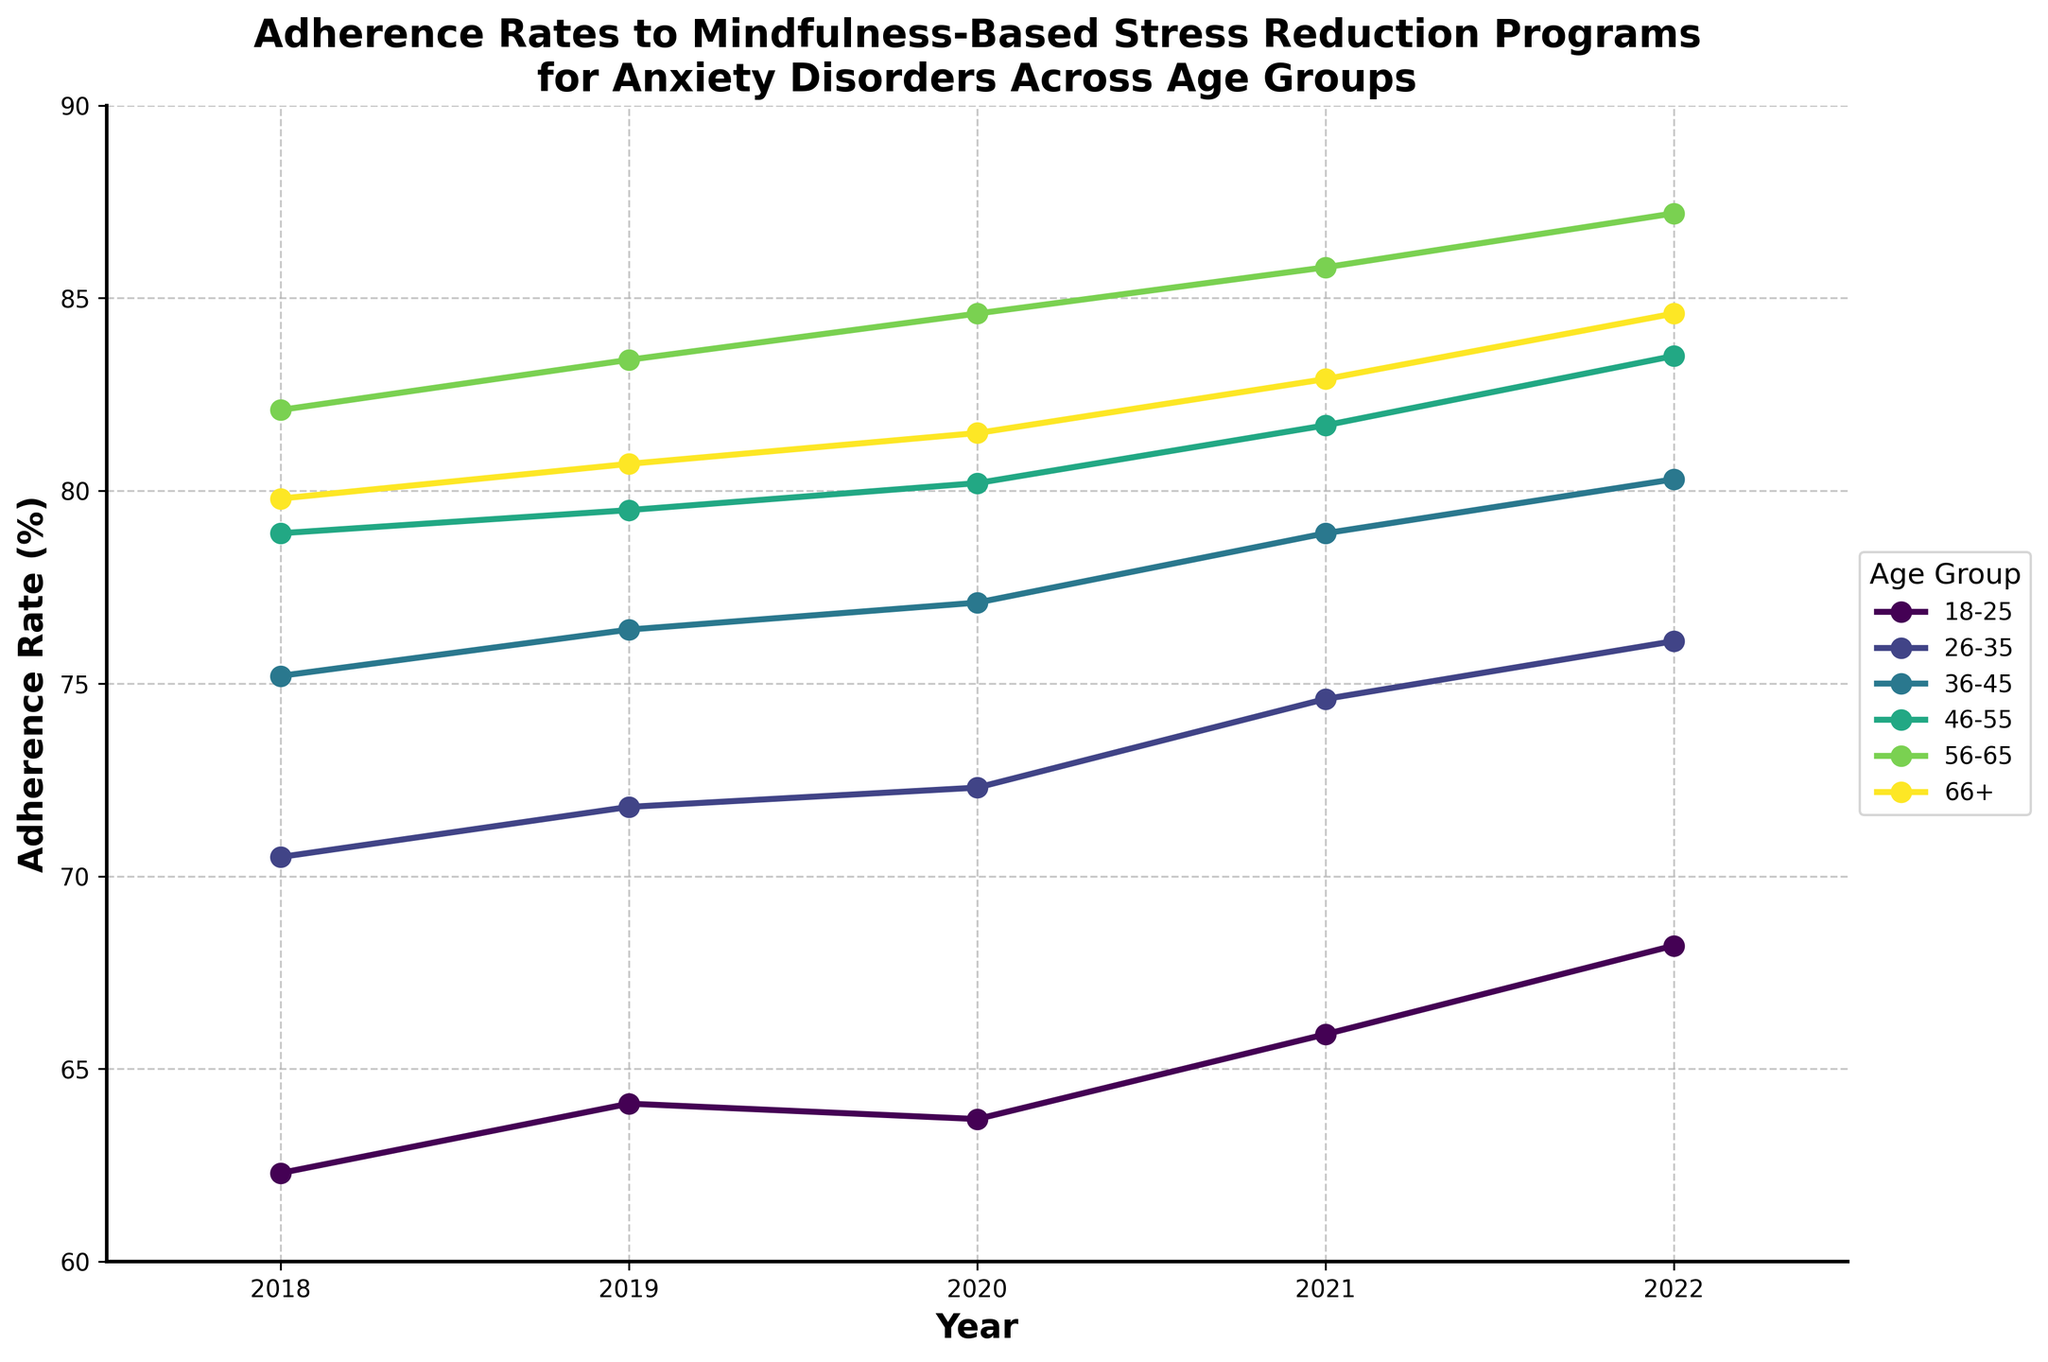Which age group has the highest adherence rate in 2022? To answer this, look at the adherence rates for each age group in 2022. The age groups have the following adherence rates: 18-25 (68.2), 26-35 (76.1), 36-45 (80.3), 46-55 (83.5), 56-65 (87.2), and 66+ (84.6). The highest adherence rate is 87.2 for the age group 56-65.
Answer: 56-65 How has the adherence rate for the 36-45 age group changed from 2018 to 2022? To find this, subtract the adherence rate in 2018 from the adherence rate in 2022 for the 36-45 age group. The adherence rates are: 2018 (75.2) and 2022 (80.3). Thus, the change is 80.3 - 75.2 = 5.1.
Answer: Increased by 5.1 Which age group showed the least improvement in adherence rate from 2018 to 2022? Calculate the difference in adherence rates from 2018 to 2022 for each age group. The differences are as follows: 18-25 (68.2 - 62.3 = 5.9), 26-35 (76.1 - 70.5 = 5.6), 36-45 (80.3 - 75.2 = 5.1), 46-55 (83.5 - 78.9 = 4.6), 56-65 (87.2 - 82.1 = 5.1), 66+ (84.6 - 79.8 = 4.8). The smallest difference is for the 46-55 age group, which is 4.6.
Answer: 46-55 Which year shows the largest overall base adherence rate increase across all age groups? Sum the adherence rates for all age groups for each year and compare the year-over-year growth. 2018: 62.3 + 70.5 + 75.2 + 78.9 + 82.1 + 79.8 = 448.8, 2019: 64.1 + 71.8 + 76.4 + 79.5 + 83.4 + 80.7 = 455.9, Δ 2019-2018 = 7.1. 2020: 63.7 + 72.3 + 77.1 + 80.2 + 84.6 + 81.5 = 459.4, Δ 2020-2019 = 3.5. 2021: 65.9 + 74.6 + 78.9 + 81.7 + 85.8 + 82.9 = 469.8, Δ 2021-2020 = 10.4. 2022: 68.2 + 76.1 + 80.3 + 83.5 + 87.2 + 84.6 = 479.9, Δ 2022-2021 = 10.1. The largest increase occurred from 2020 to 2021.
Answer: 2021 How does the adherence rate for the 66+ age group in 2022 compare to the adherence rate for the 18-25 age group in the same year? Compare the adherence rates for the age groups 66+ and 18-25 in 2022. The adherence rate for 66+ is 84.6, and for 18-25 it is 68.2. 84.6 - 68.2 = 16.4, so the 66+ age group's adherence rate is 16.4 percentage points higher than the 18-25 age group's rate in 2022.
Answer: 16.4 percentage points higher What is the average adherence rate across all age groups in 2021? Calculate the adherence rates for each age group in 2021: 18-25 (65.9), 26-35 (74.6), 36-45 (78.9), 46-55 (81.7), 56-65 (85.8), 66+ (82.9). Sum these rates and divide by the number of age groups: (65.9 + 74.6 + 78.9 + 81.7 + 85.8 + 82.9) / 6 = 78.3.
Answer: 78.3 Which age group had the most consistent adherence rate increase over the years 2018 to 2022? Analyze the differences year-by-year for each age group:
- 18-25: 1.8 (2019), -0.4 (2020), 2.2 (2021), 2.3 (2022).
- 26-35: 1.3 (2019), 0.5 (2020), 2.3 (2021), 1.5 (2022).
- 36-45: 1.2 (2019), 0.7 (2020), 1.8 (2021), 1.4 (2022).
- 46-55: 0.6 (2019), 0.7 (2020), 1.5 (2021), 1.8 (2022).
- 56-65: 1.3 (2019), 1.2 (2020), 1.2 (2021), 1.4 (2022).
- 66+: 0.9 (2019), 0.8 (2020), 1.4 (2021), 1.7 (2022).
56-65 has the most consistent increase with small, steady increments each year.
Answer: 56-65 Do the adherence rates of any two age groups converge in 2022? Compare the adherence rates of all age groups in 2022. Notice that the 56-65 and 66+ groups have rates of 87.2 and 84.6, respectively, which are fairly close but not exactly converging. No two groups have rates that meet or cross exactly in 2022.
Answer: No 